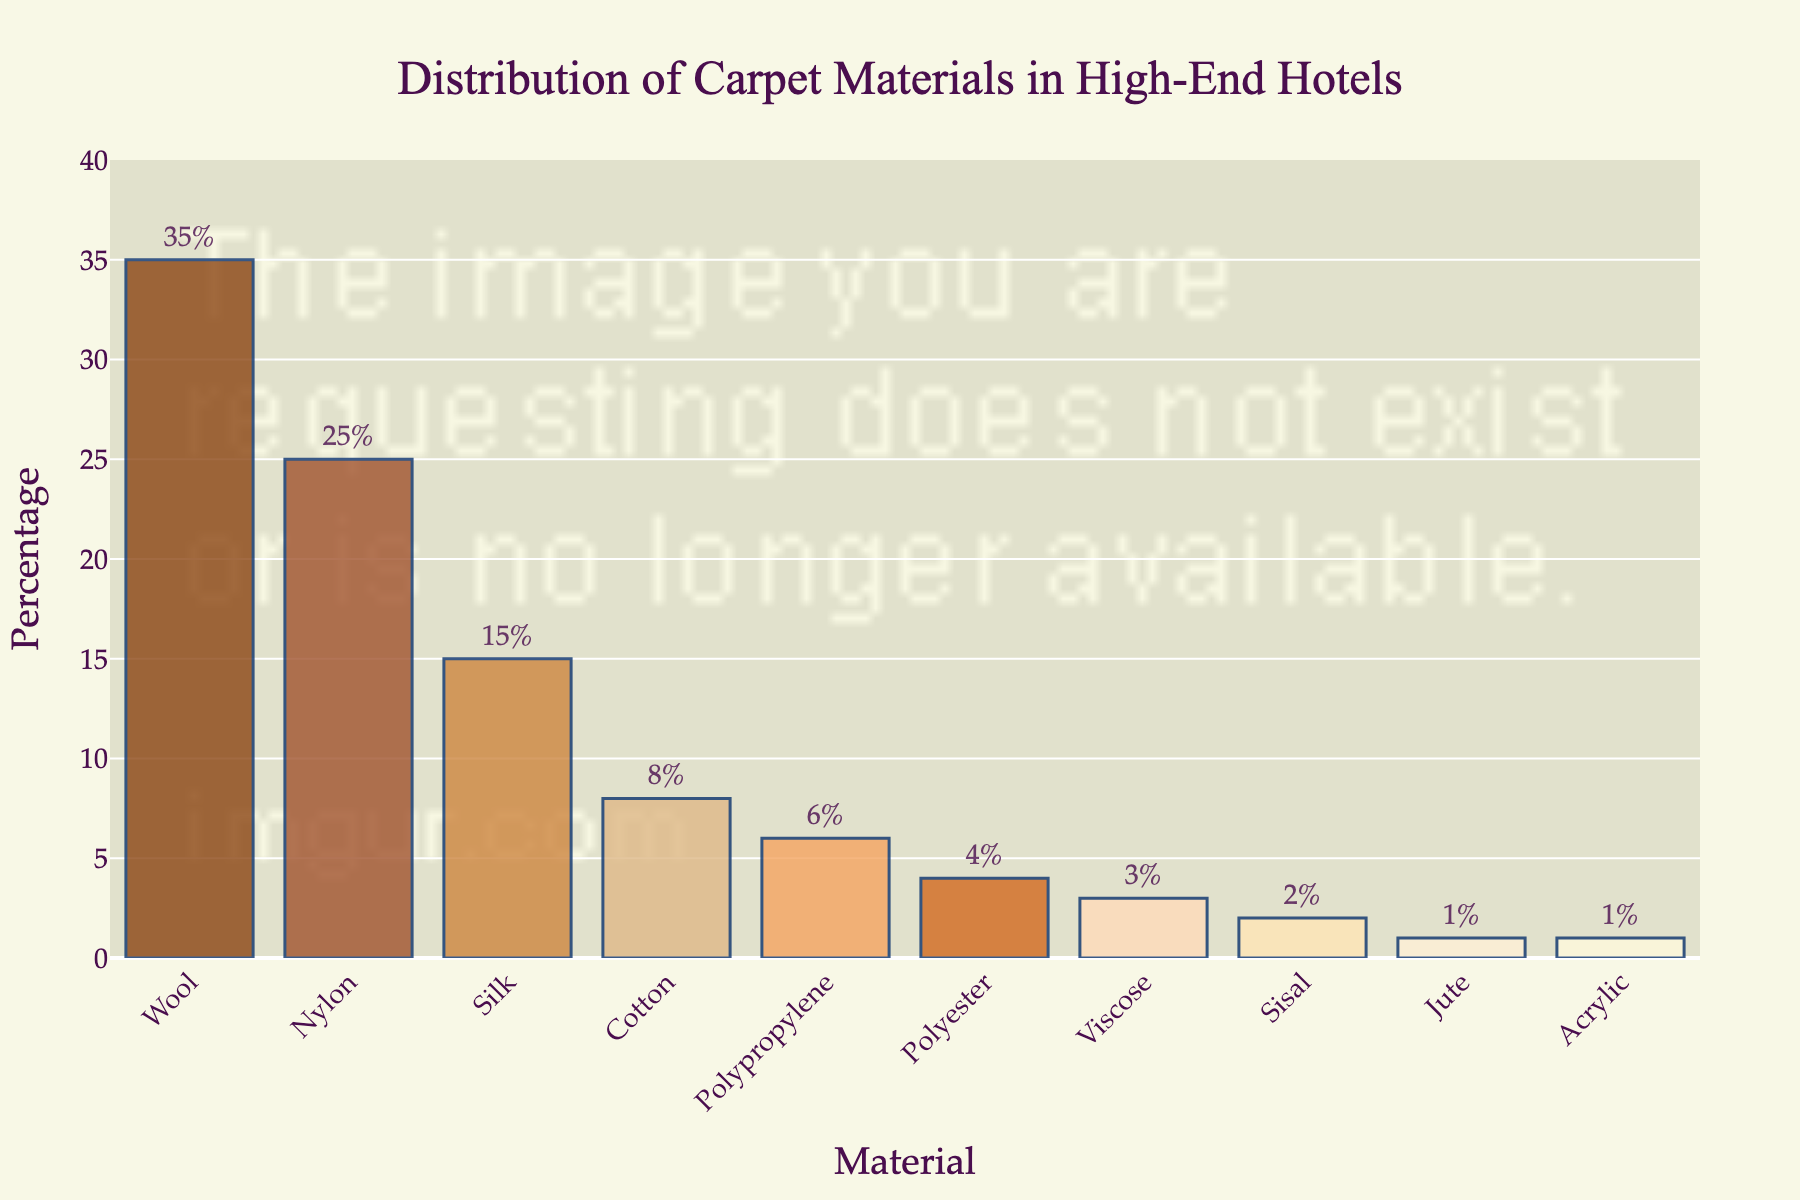Which material is used the most for carpets in high-end hotels? The material with the highest bar and percentage value indicates the most frequently used material.
Answer: Wool Which material has the lowest percentage usage among all listed in the figure? The material with the shortest bar and the smallest percentage value indicates the least used material.
Answer: Jute and Acrylic What is the combined percentage of Nylon, Silk, and Cotton? Add the percentages for Nylon (25%), Silk (15%), and Cotton (8%). The sum is 25 + 15 + 8 = 48.
Answer: 48% How much more percentage of Wool is used compared to Polypropylene? Subtract the percentage of Polypropylene (6%) from Wool (35%). The difference is 35 - 6 = 29.
Answer: 29% How do the usage percentages of Polyester and Viscose compare? Compare the bars for Polyester and Viscose. Polyester has a percentage of 4%, and Viscose has a percentage of 3%.
Answer: Polyester is used more What are the total percentages of natural materials (Wool, Silk, Cotton, Sisal, Jute) used? Add the percentages for Wool (35%), Silk (15%), Cotton (8%), Sisal (2%), and Jute (1%). The total is 35 + 15 + 8 + 2 + 1 = 61.
Answer: 61% Is the percentage of Nylon usage higher than 20%? Look at the percentage value for Nylon, which is 25%, and compare it with 20%.
Answer: Yes How many materials have a usage percentage lower than 10%? Count the materials with percentages lower than 10%: Cotton (8%), Polypropylene (6%), Polyester (4%), Viscose (3%), Sisal (2%), Jute (1%), and Acrylic (1%). There are 7 materials in total.
Answer: 7 Which materials together make up more than half of the total usage? Calculate the sum of the highest percentages sequentially until it exceeds 50%. Wool (35%) + Nylon (25%) = 60%.
Answer: Wool and Nylon 